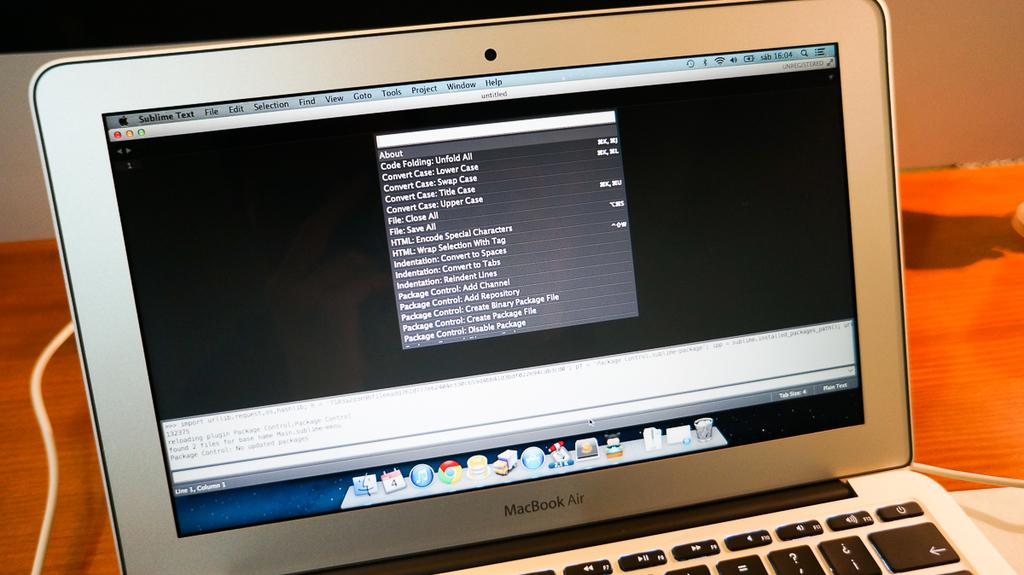<image>
Describe the image concisely. A macbook sits on a tabletop with a browser open. 